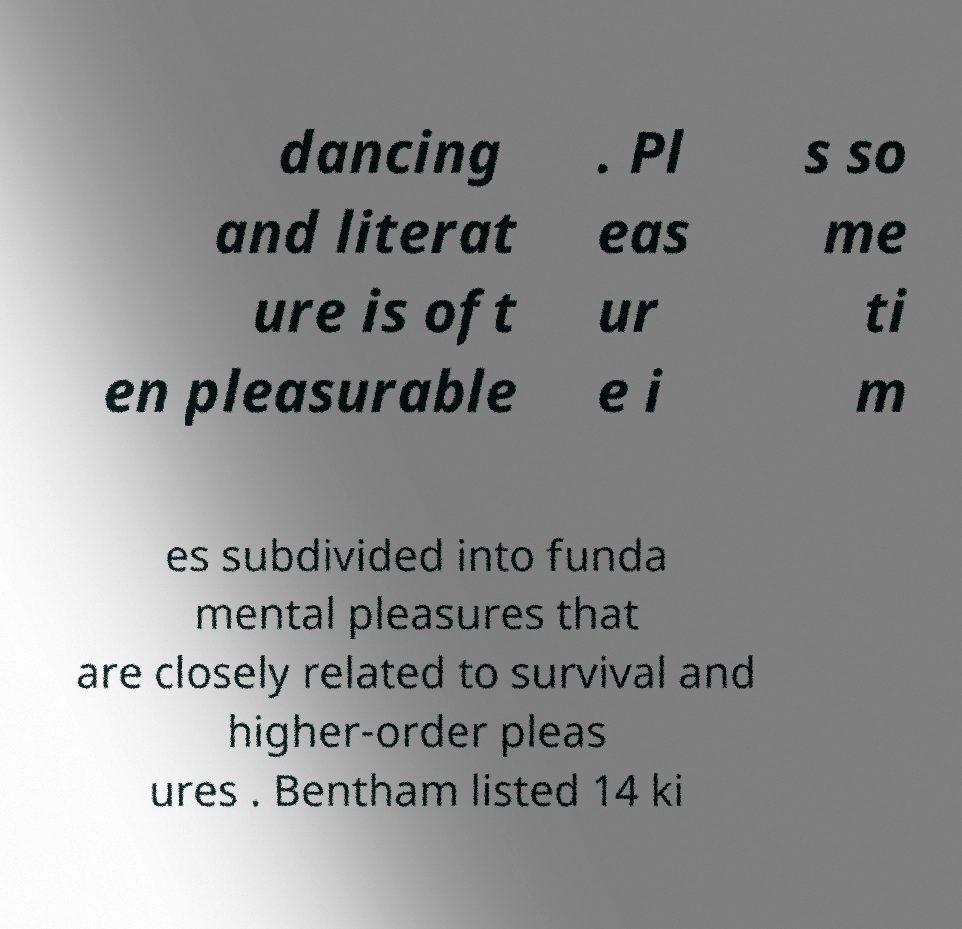There's text embedded in this image that I need extracted. Can you transcribe it verbatim? dancing and literat ure is oft en pleasurable . Pl eas ur e i s so me ti m es subdivided into funda mental pleasures that are closely related to survival and higher-order pleas ures . Bentham listed 14 ki 